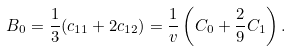<formula> <loc_0><loc_0><loc_500><loc_500>B _ { 0 } = { \frac { 1 } { 3 } } ( c _ { 1 1 } + 2 c _ { 1 2 } ) = \frac { 1 } { v } \left ( C _ { 0 } + { \frac { 2 } { 9 } } C _ { 1 } \right ) .</formula> 